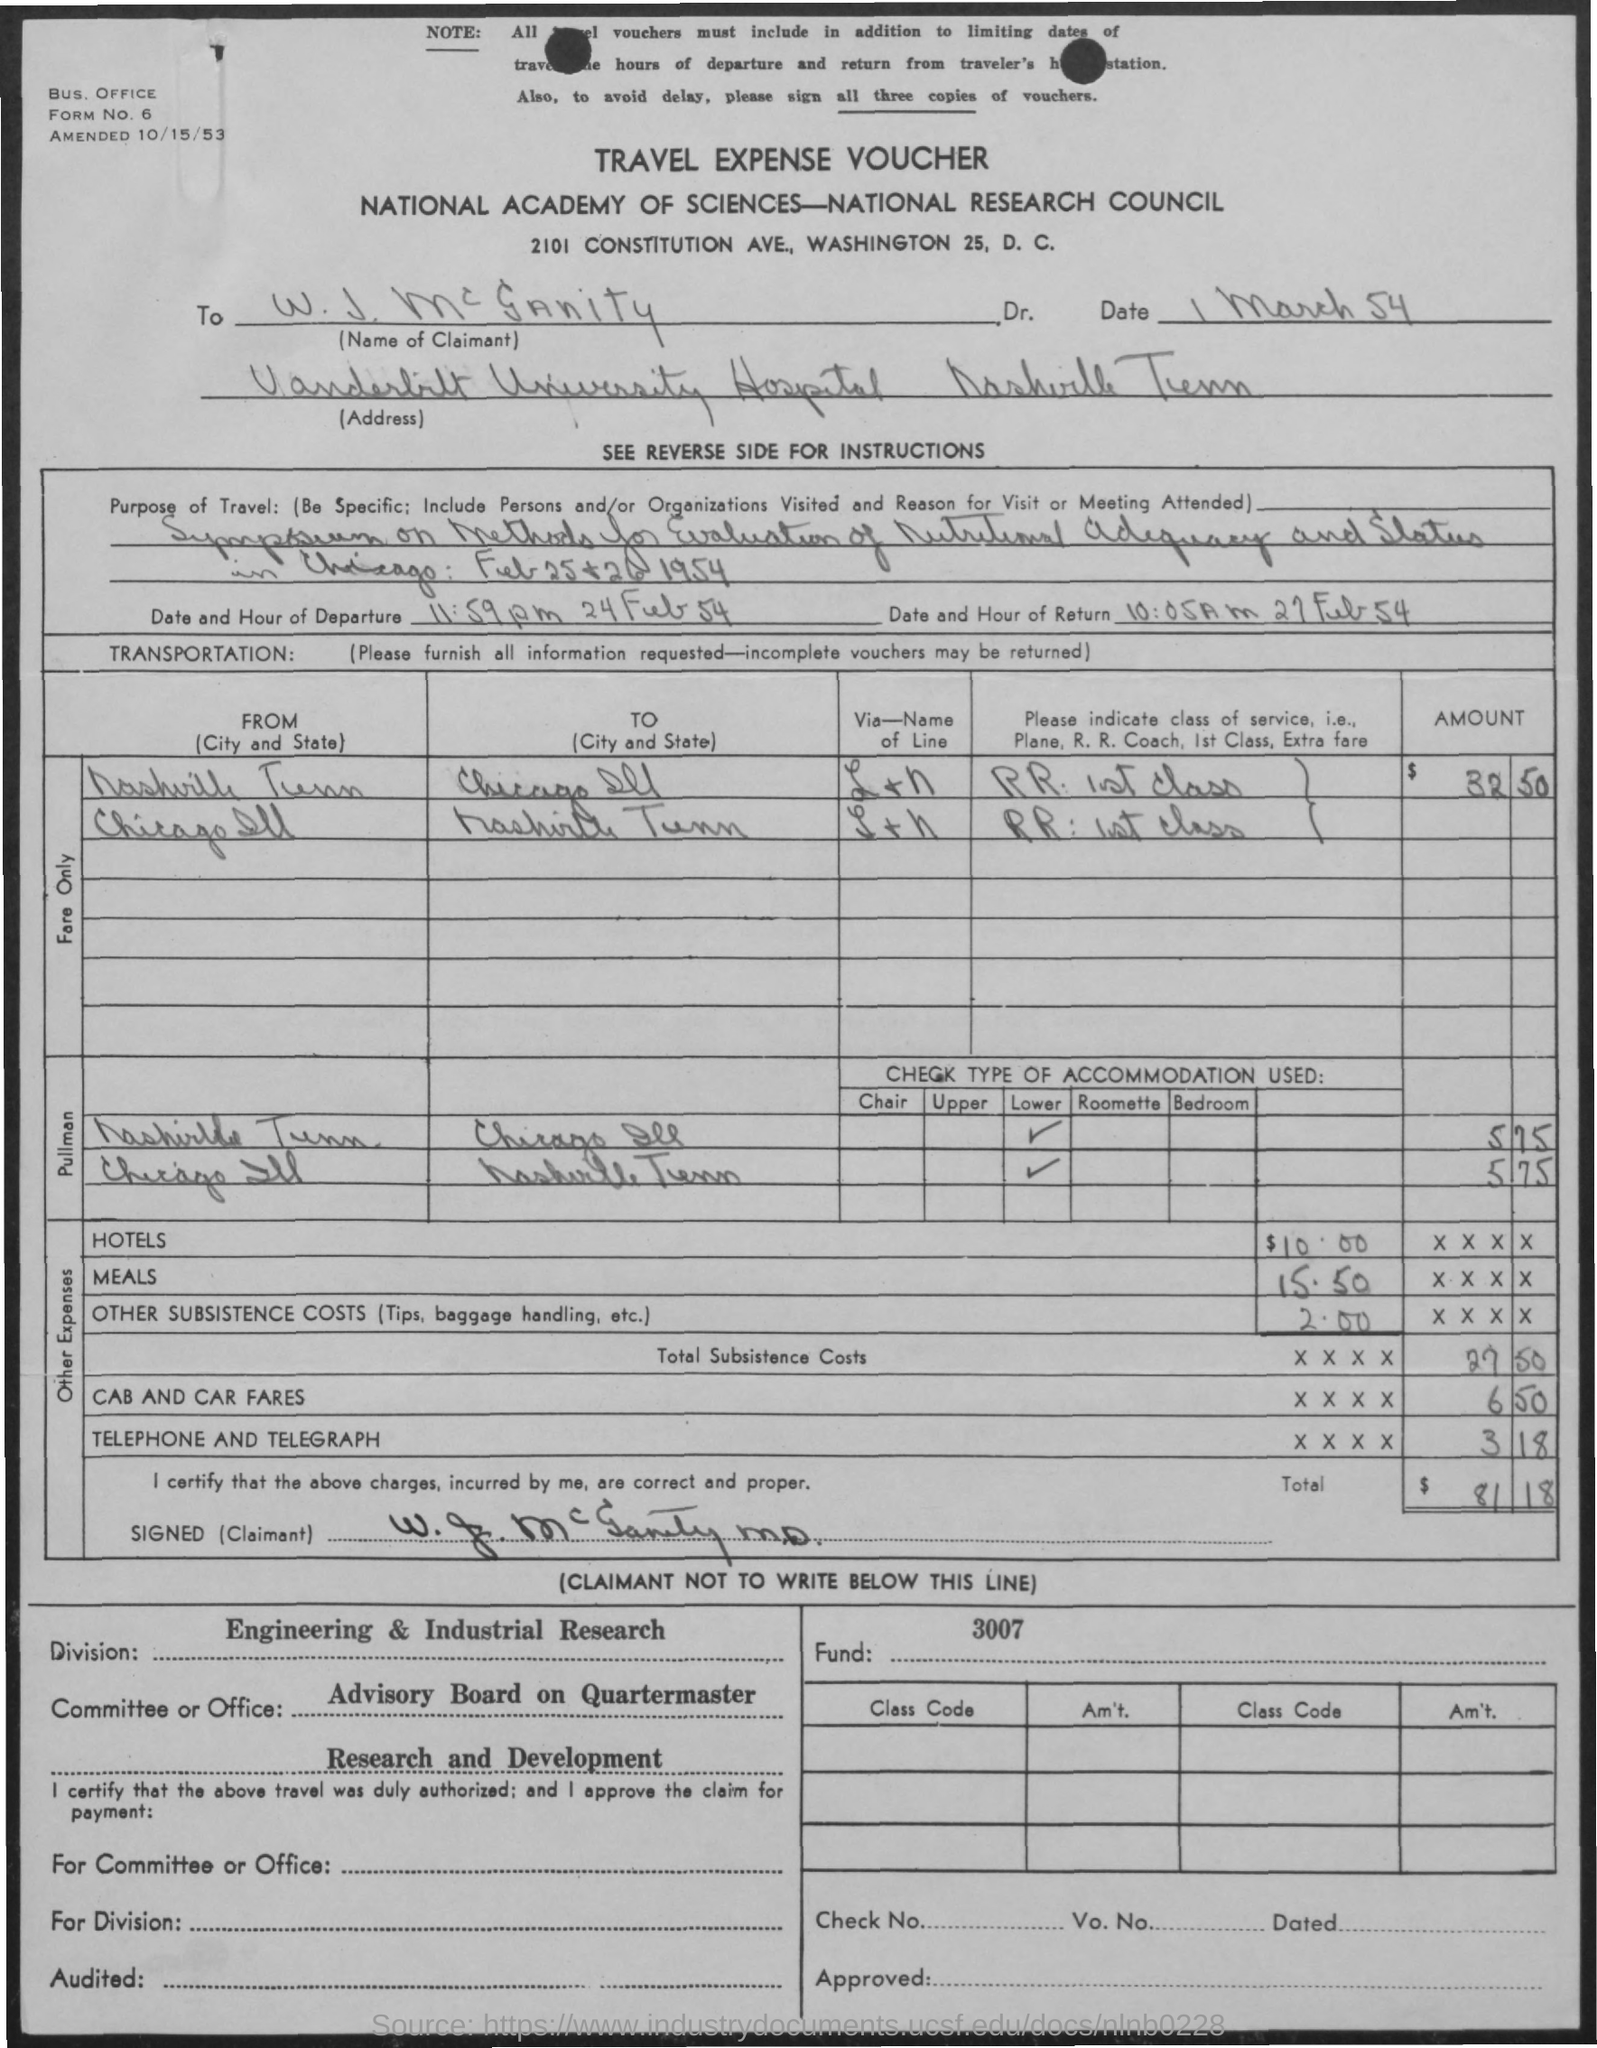What was the purpose of the travel according to the document? The purpose of travel, as stated in the document, was for 'Inspection and Testing of rations of National Advisory Committee and Tropical Survival Gear.' It was related to activities involving sustenance for military or exploration purposes in tropical environments. 